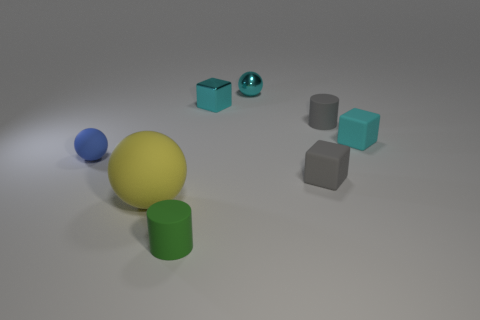What is the color of the small matte object that is the same shape as the big thing? blue 